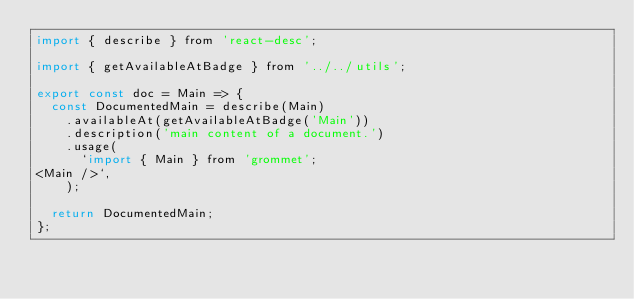Convert code to text. <code><loc_0><loc_0><loc_500><loc_500><_JavaScript_>import { describe } from 'react-desc';

import { getAvailableAtBadge } from '../../utils';

export const doc = Main => {
  const DocumentedMain = describe(Main)
    .availableAt(getAvailableAtBadge('Main'))
    .description('main content of a document.')
    .usage(
      `import { Main } from 'grommet';
<Main />`,
    );

  return DocumentedMain;
};
</code> 